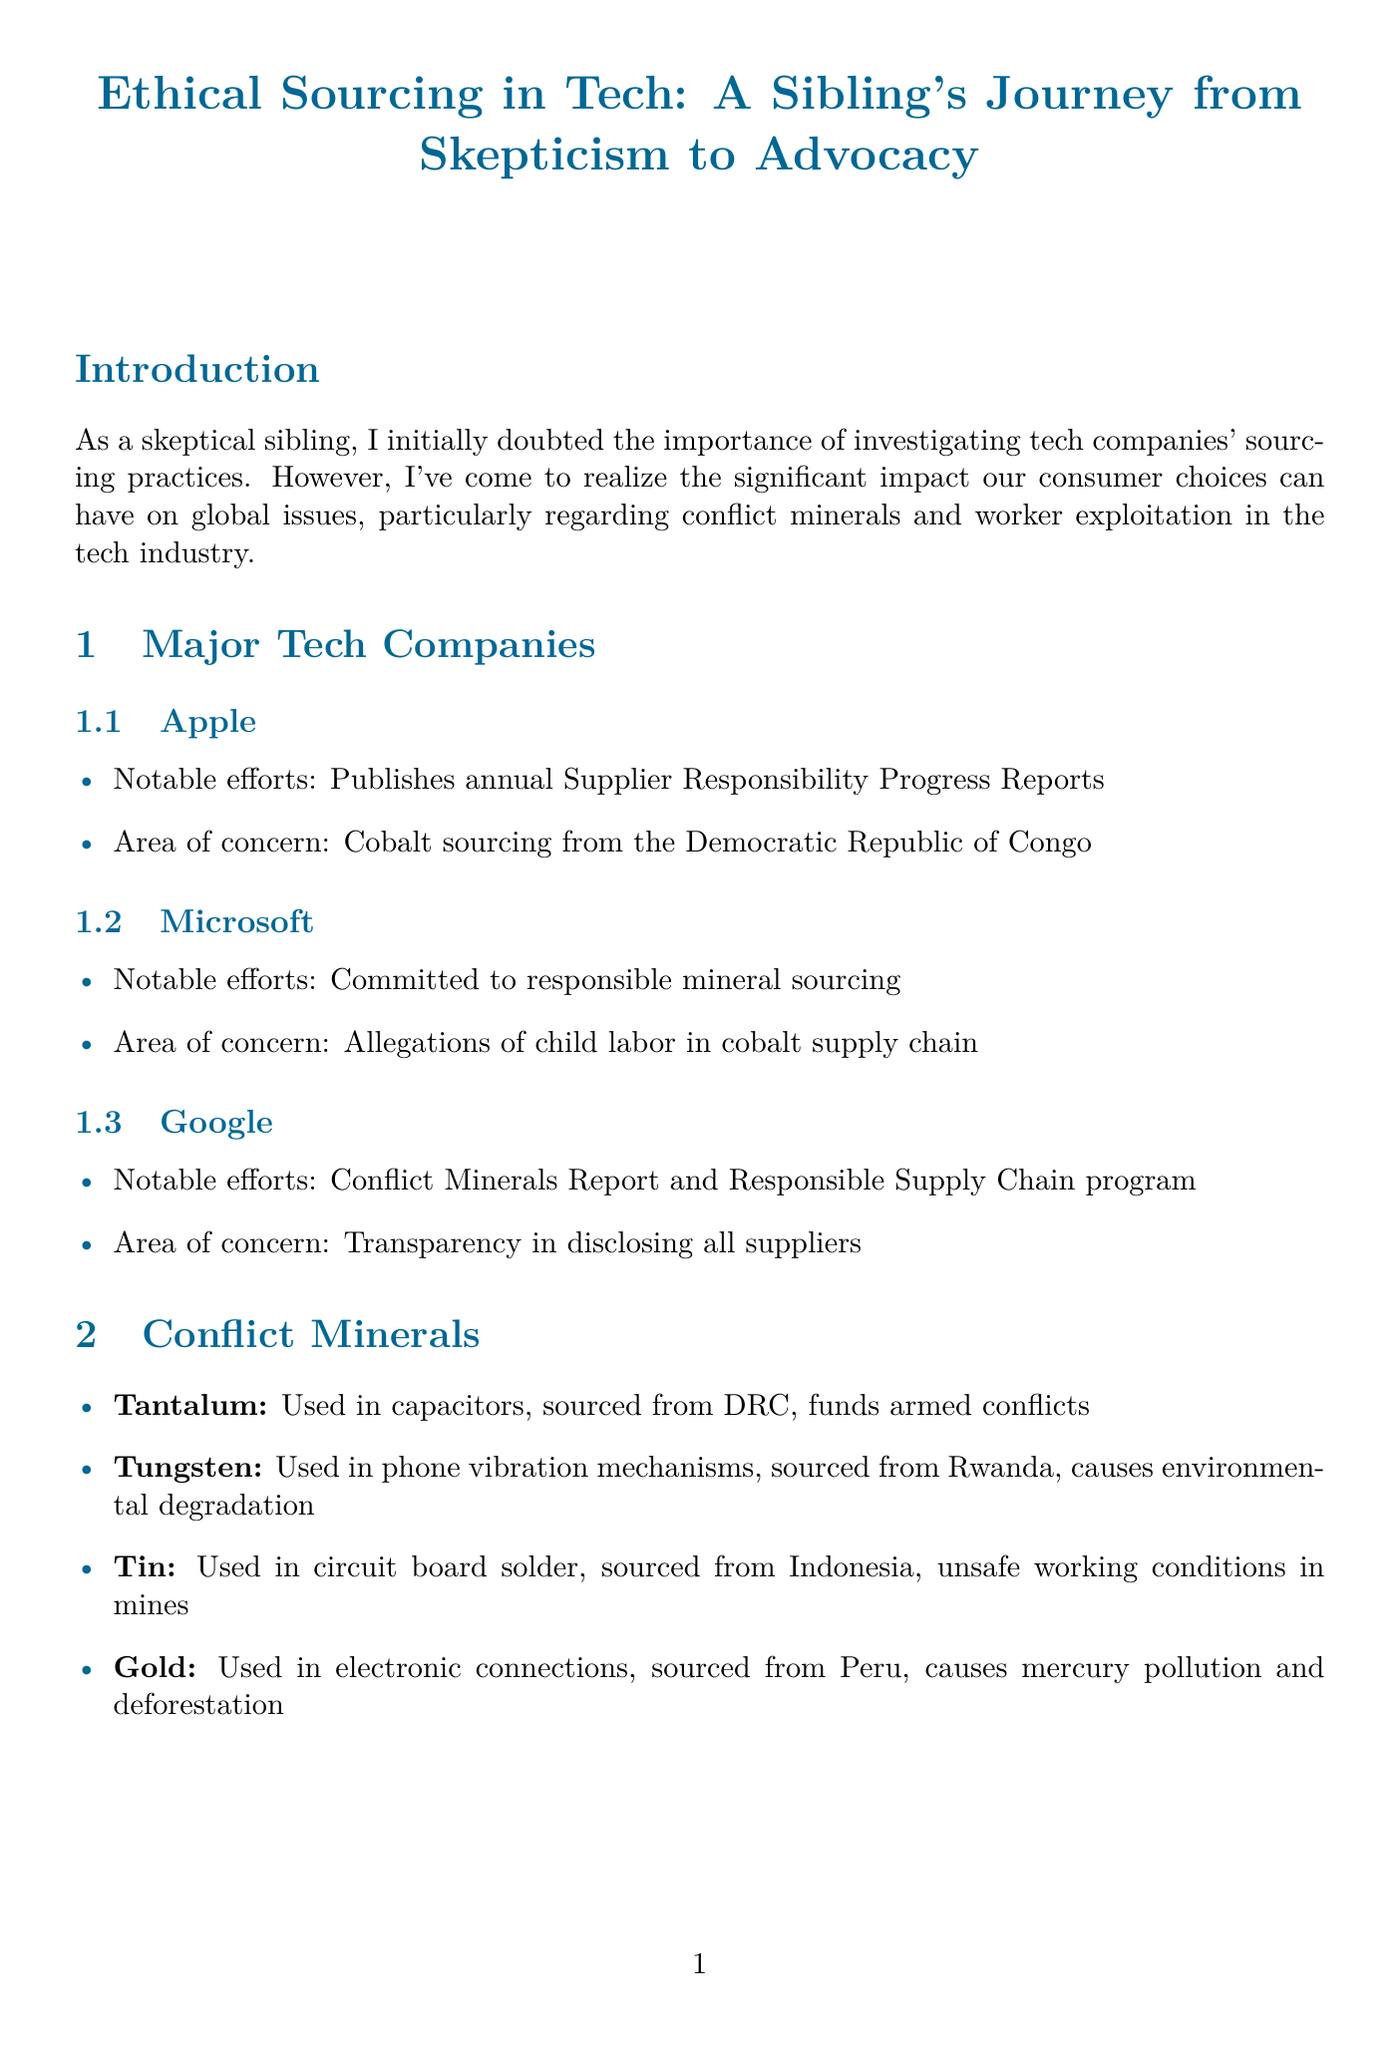What is the purpose of the Responsible Minerals Initiative? The Responsible Minerals Initiative aims to provide companies with tools and resources for responsible sourcing decisions.
Answer: Provide tools for responsible sourcing decisions Which company publishes annual Supplier Responsibility Progress Reports? Apple is known for publishing annual Supplier Responsibility Progress Reports.
Answer: Apple How many companies participate in the Responsible Minerals Initiative? The document states that over 380 companies and associations participate in this initiative.
Answer: Over 380 What is a major ethical concern associated with tantalum? The primary ethical concern linked to tantalum is that it funds armed conflicts and human rights abuses.
Answer: Funding armed conflicts and human rights abuses What impact does low wages have on workers according to the document? The document identifies that low wages perpetuate poverty cycles.
Answer: Perpetuation of poverty cycles 